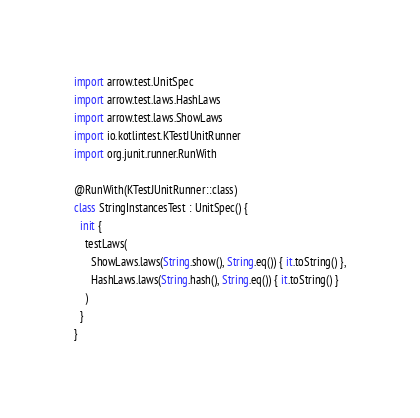Convert code to text. <code><loc_0><loc_0><loc_500><loc_500><_Kotlin_>import arrow.test.UnitSpec
import arrow.test.laws.HashLaws
import arrow.test.laws.ShowLaws
import io.kotlintest.KTestJUnitRunner
import org.junit.runner.RunWith

@RunWith(KTestJUnitRunner::class)
class StringInstancesTest : UnitSpec() {
  init {
    testLaws(
      ShowLaws.laws(String.show(), String.eq()) { it.toString() },
      HashLaws.laws(String.hash(), String.eq()) { it.toString() }
    )
  }
}
</code> 